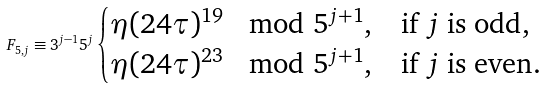<formula> <loc_0><loc_0><loc_500><loc_500>F _ { 5 , j } \equiv 3 ^ { j - 1 } 5 ^ { j } \begin{cases} \eta ( 2 4 \tau ) ^ { 1 9 } \mod 5 ^ { j + 1 } , & \text {if } j \text { is odd} , \\ \eta ( 2 4 \tau ) ^ { 2 3 } \mod 5 ^ { j + 1 } , & \text {if } j \text { is even} . \end{cases}</formula> 